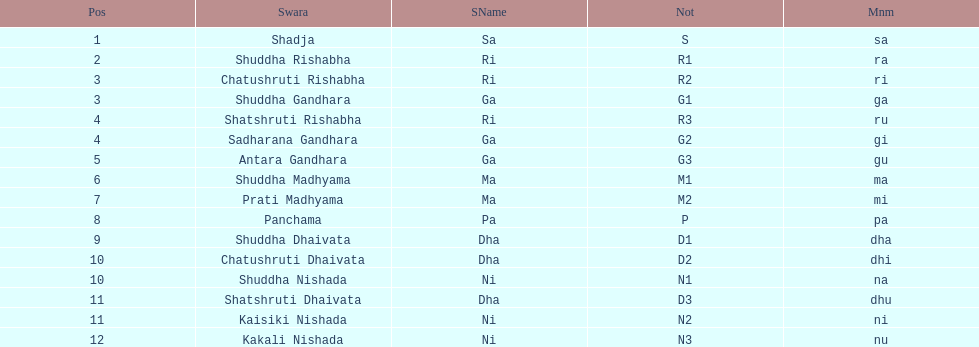What is the total number of positions listed? 16. 